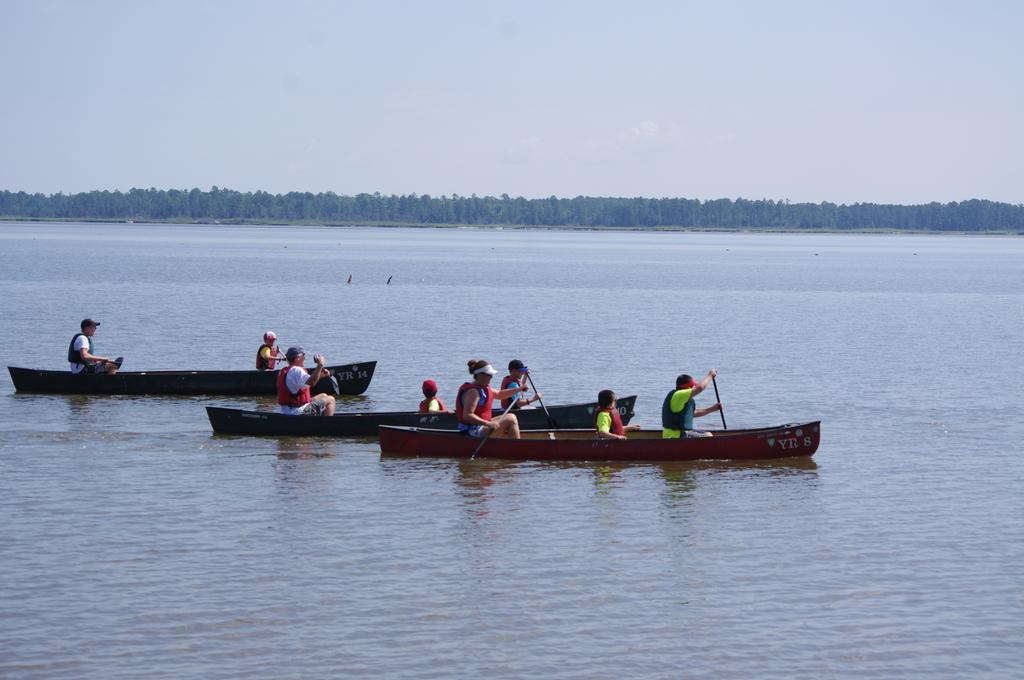What activity are the people in the image engaged in? The people in the image are sailing boats. Where are the boats located? The boats are on the water. What can be seen in the background of the image? There are trees visible in the background of the image. What brand of toothpaste is being used by the people sailing the boats in the image? There is no toothpaste present in the image, as the people are sailing boats on the water. 